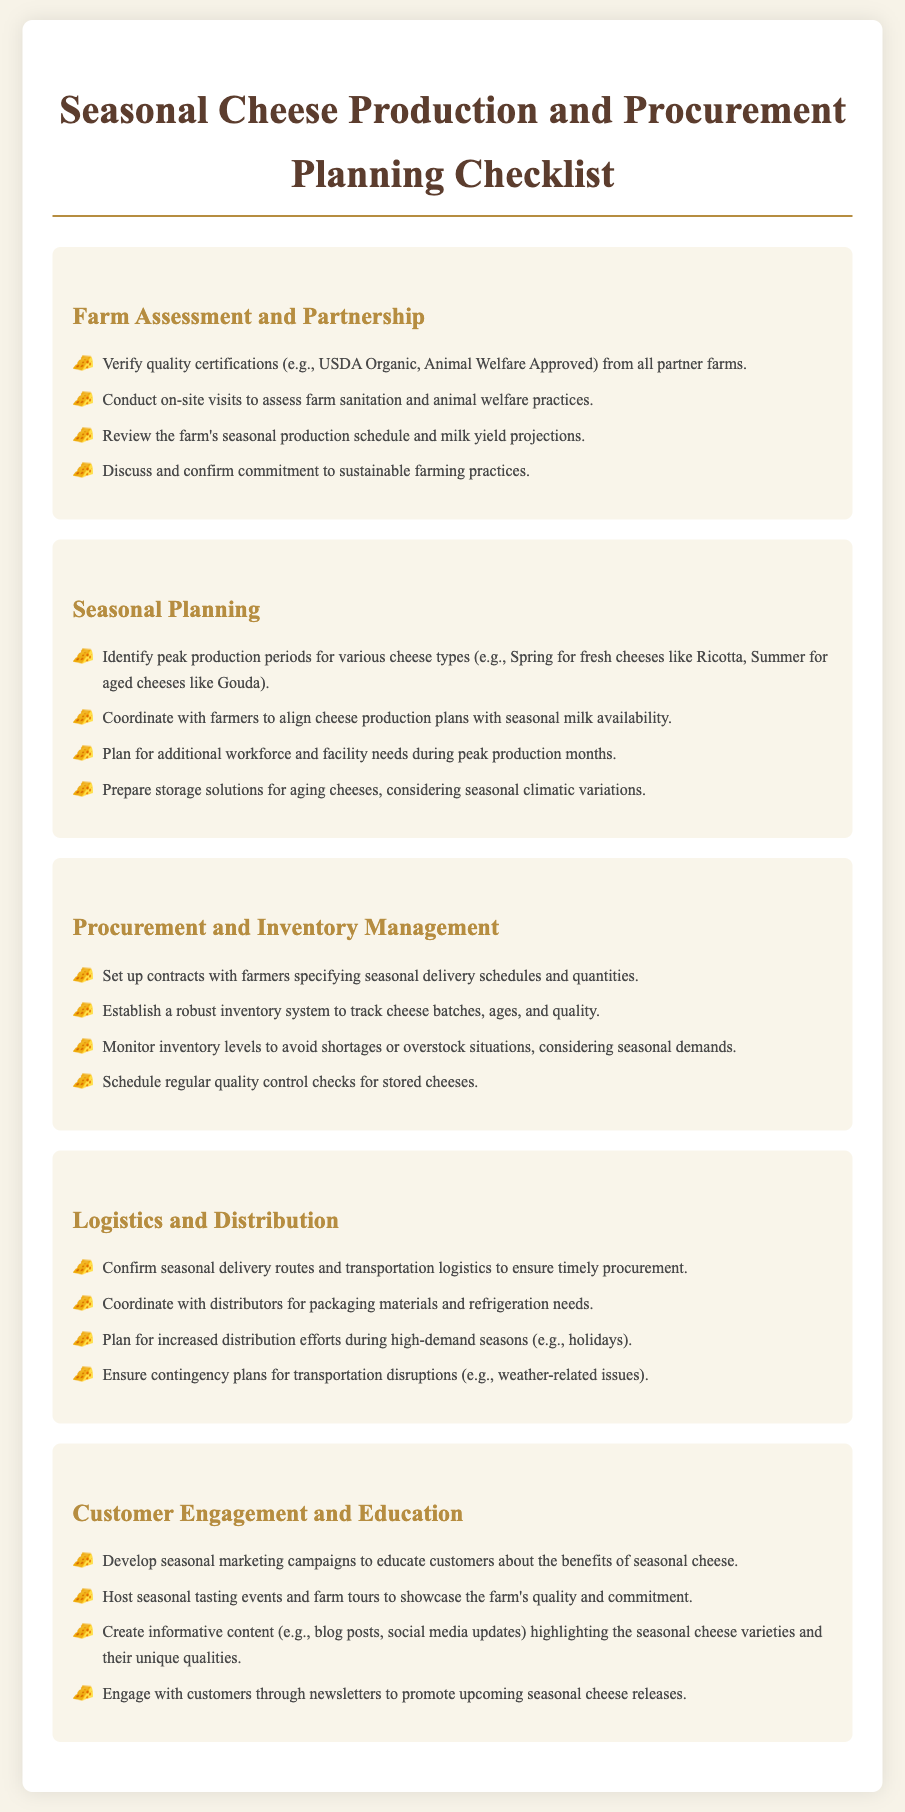What is verified in the farm assessment? The checklist states to verify quality certifications from all partner farms.
Answer: Quality certifications What seasonal cheese type peaks in Spring? The document identifies fresh cheeses like Ricotta as being produced in Spring.
Answer: Ricotta How many sections are in the document? The document contains five main sections related to the checklist topics.
Answer: Five What is one of the key factors to discuss with farmers? The checklist emphasizes discussing and confirming commitment to sustainable farming practices.
Answer: Sustainable farming practices What seasonal marketing strategies are mentioned? The checklist suggests developing seasonal marketing campaigns to educate customers about cheese.
Answer: Seasonal marketing campaigns What is established for inventory management? The checklist mentions establishing a robust inventory system to track cheese batches.
Answer: Robust inventory system How often should quality control checks be scheduled? The checklist suggests to schedule regular quality control checks for stored cheeses.
Answer: Regularly What should be coordinated with distributors? The document highlights coordinating with distributors for packaging materials and refrigeration needs.
Answer: Packaging materials What are seasonal tasting events meant to showcase? The checklist indicates that seasonal tasting events should showcase the farm's quality and commitment.
Answer: Farm's quality and commitment 